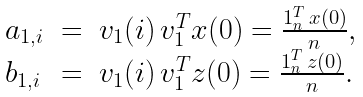<formula> <loc_0><loc_0><loc_500><loc_500>\begin{array} { l l l l l l } a _ { 1 , i } & = & v _ { 1 } ( i ) \, v _ { 1 } ^ { T } x ( 0 ) = \frac { 1 _ { n } ^ { T } \, x ( 0 ) } { n } , \\ b _ { 1 , i } & = & v _ { 1 } ( i ) \, v _ { 1 } ^ { T } z ( 0 ) = \frac { 1 _ { n } ^ { T } \, z ( 0 ) } { n } . \end{array}</formula> 